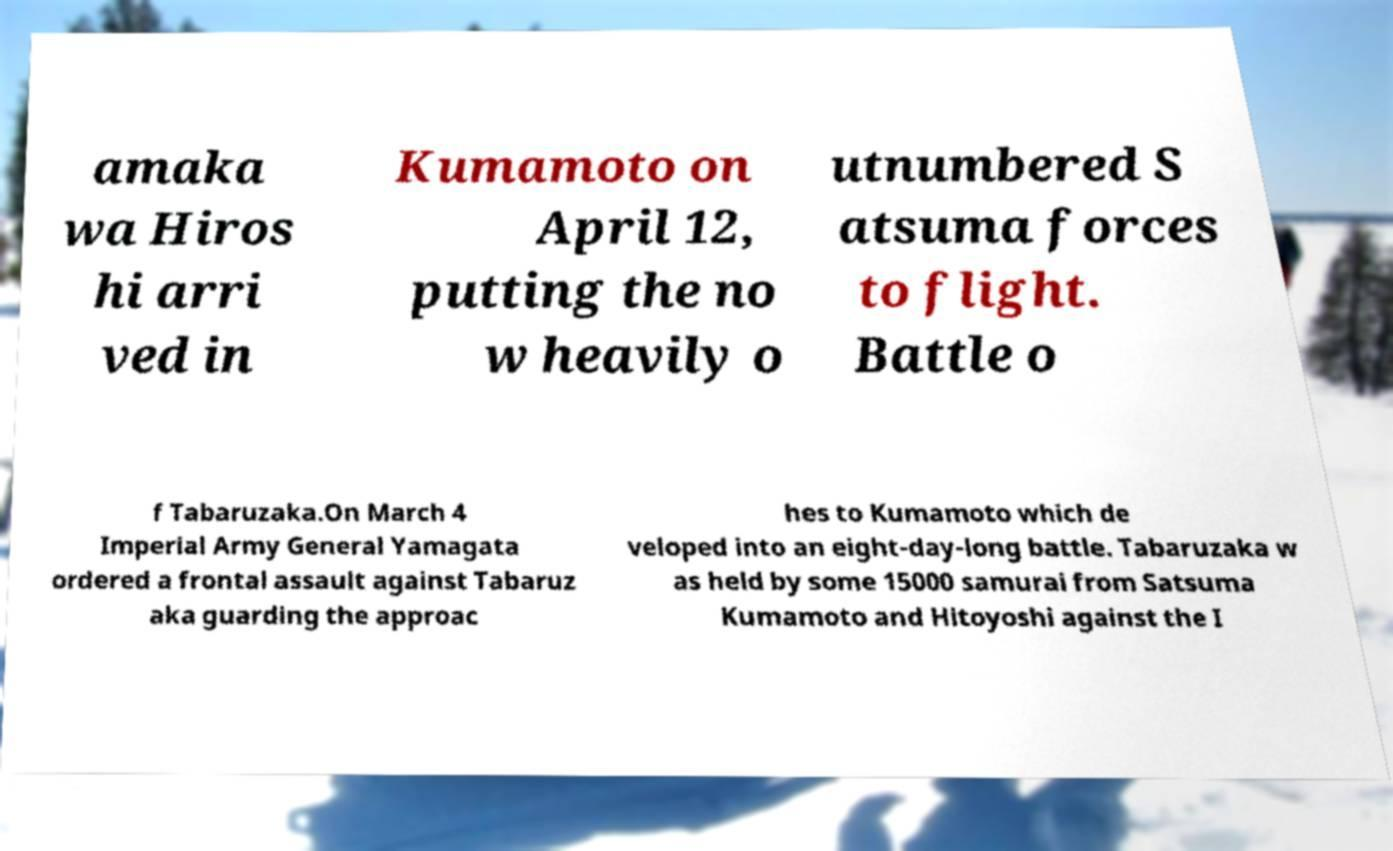There's text embedded in this image that I need extracted. Can you transcribe it verbatim? amaka wa Hiros hi arri ved in Kumamoto on April 12, putting the no w heavily o utnumbered S atsuma forces to flight. Battle o f Tabaruzaka.On March 4 Imperial Army General Yamagata ordered a frontal assault against Tabaruz aka guarding the approac hes to Kumamoto which de veloped into an eight-day-long battle. Tabaruzaka w as held by some 15000 samurai from Satsuma Kumamoto and Hitoyoshi against the I 